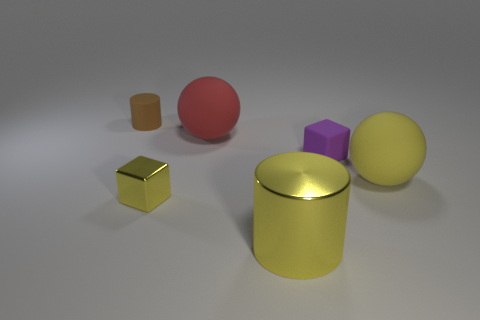Subtract all cyan blocks. Subtract all brown spheres. How many blocks are left? 2 Add 1 tiny green rubber things. How many objects exist? 7 Subtract all cubes. How many objects are left? 4 Subtract all large green shiny things. Subtract all red balls. How many objects are left? 5 Add 4 small matte cylinders. How many small matte cylinders are left? 5 Add 4 big blocks. How many big blocks exist? 4 Subtract 1 yellow balls. How many objects are left? 5 